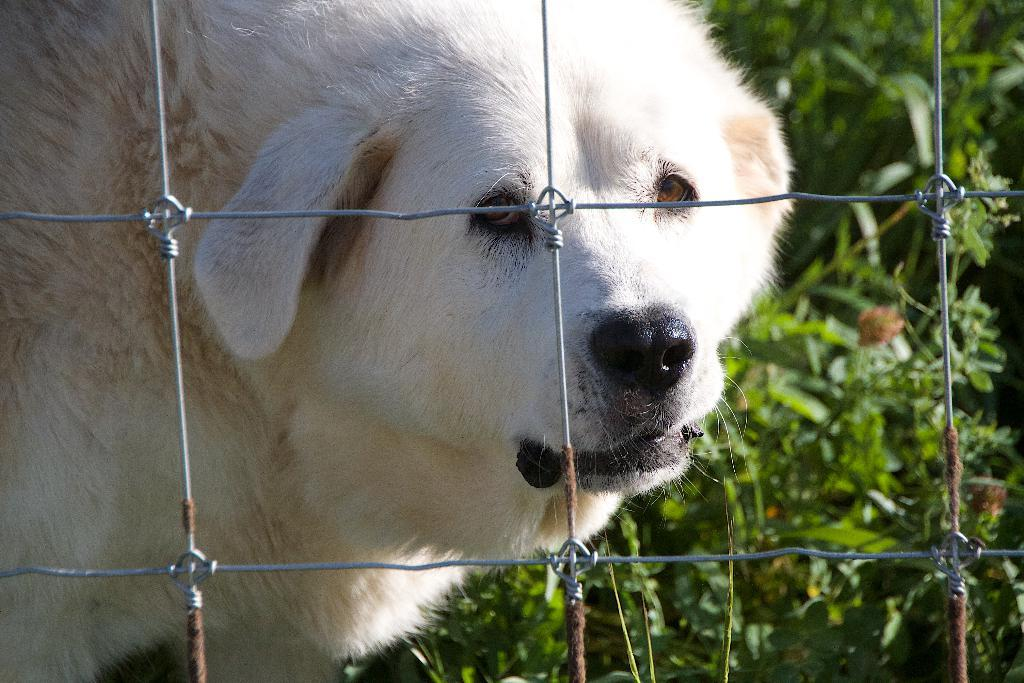What type of animal can be seen in the image? There is a dog in the image. What is located in the foreground of the image? There is a mesh in the foreground of the image. What can be seen in the background of the image? There are trees in the background of the image. How many boys are present in the image? There is no boy present in the image; it features a dog, mesh, and trees. What type of boats can be seen in the image? There are no boats present in the image. 